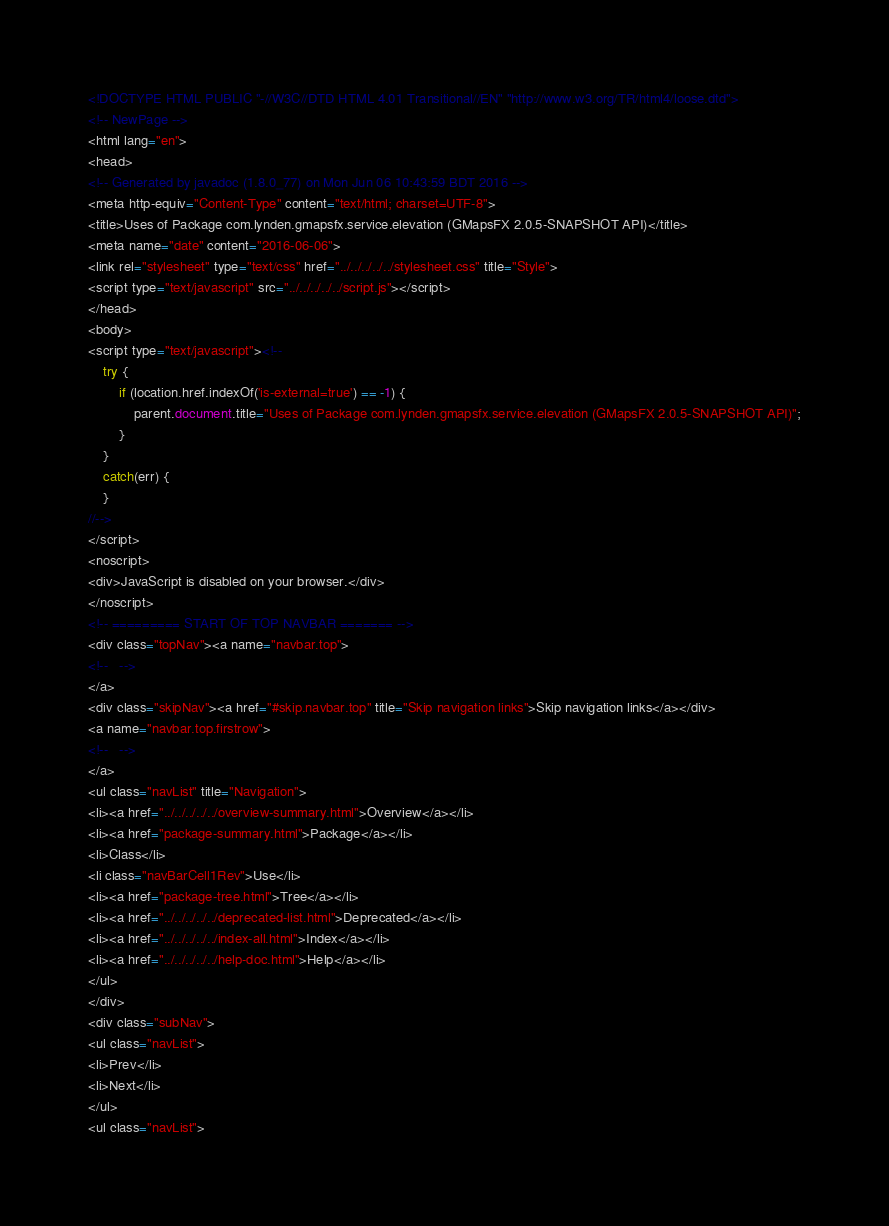<code> <loc_0><loc_0><loc_500><loc_500><_HTML_><!DOCTYPE HTML PUBLIC "-//W3C//DTD HTML 4.01 Transitional//EN" "http://www.w3.org/TR/html4/loose.dtd">
<!-- NewPage -->
<html lang="en">
<head>
<!-- Generated by javadoc (1.8.0_77) on Mon Jun 06 10:43:59 BDT 2016 -->
<meta http-equiv="Content-Type" content="text/html; charset=UTF-8">
<title>Uses of Package com.lynden.gmapsfx.service.elevation (GMapsFX 2.0.5-SNAPSHOT API)</title>
<meta name="date" content="2016-06-06">
<link rel="stylesheet" type="text/css" href="../../../../../stylesheet.css" title="Style">
<script type="text/javascript" src="../../../../../script.js"></script>
</head>
<body>
<script type="text/javascript"><!--
    try {
        if (location.href.indexOf('is-external=true') == -1) {
            parent.document.title="Uses of Package com.lynden.gmapsfx.service.elevation (GMapsFX 2.0.5-SNAPSHOT API)";
        }
    }
    catch(err) {
    }
//-->
</script>
<noscript>
<div>JavaScript is disabled on your browser.</div>
</noscript>
<!-- ========= START OF TOP NAVBAR ======= -->
<div class="topNav"><a name="navbar.top">
<!--   -->
</a>
<div class="skipNav"><a href="#skip.navbar.top" title="Skip navigation links">Skip navigation links</a></div>
<a name="navbar.top.firstrow">
<!--   -->
</a>
<ul class="navList" title="Navigation">
<li><a href="../../../../../overview-summary.html">Overview</a></li>
<li><a href="package-summary.html">Package</a></li>
<li>Class</li>
<li class="navBarCell1Rev">Use</li>
<li><a href="package-tree.html">Tree</a></li>
<li><a href="../../../../../deprecated-list.html">Deprecated</a></li>
<li><a href="../../../../../index-all.html">Index</a></li>
<li><a href="../../../../../help-doc.html">Help</a></li>
</ul>
</div>
<div class="subNav">
<ul class="navList">
<li>Prev</li>
<li>Next</li>
</ul>
<ul class="navList"></code> 